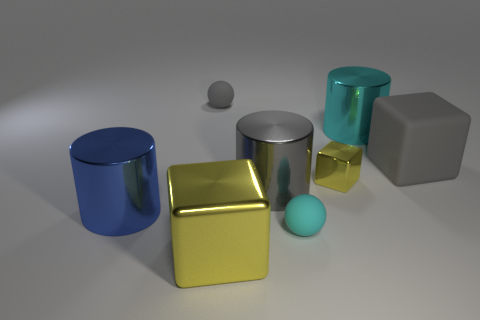Subtract all yellow shiny cubes. How many cubes are left? 1 Subtract 1 cylinders. How many cylinders are left? 2 Add 1 big gray blocks. How many objects exist? 9 Subtract all cylinders. How many objects are left? 5 Add 1 large gray rubber blocks. How many large gray rubber blocks exist? 2 Subtract 1 gray cylinders. How many objects are left? 7 Subtract all big yellow blocks. Subtract all rubber things. How many objects are left? 4 Add 7 shiny cylinders. How many shiny cylinders are left? 10 